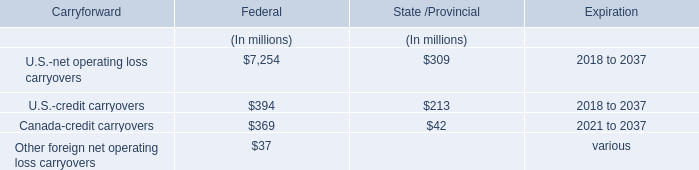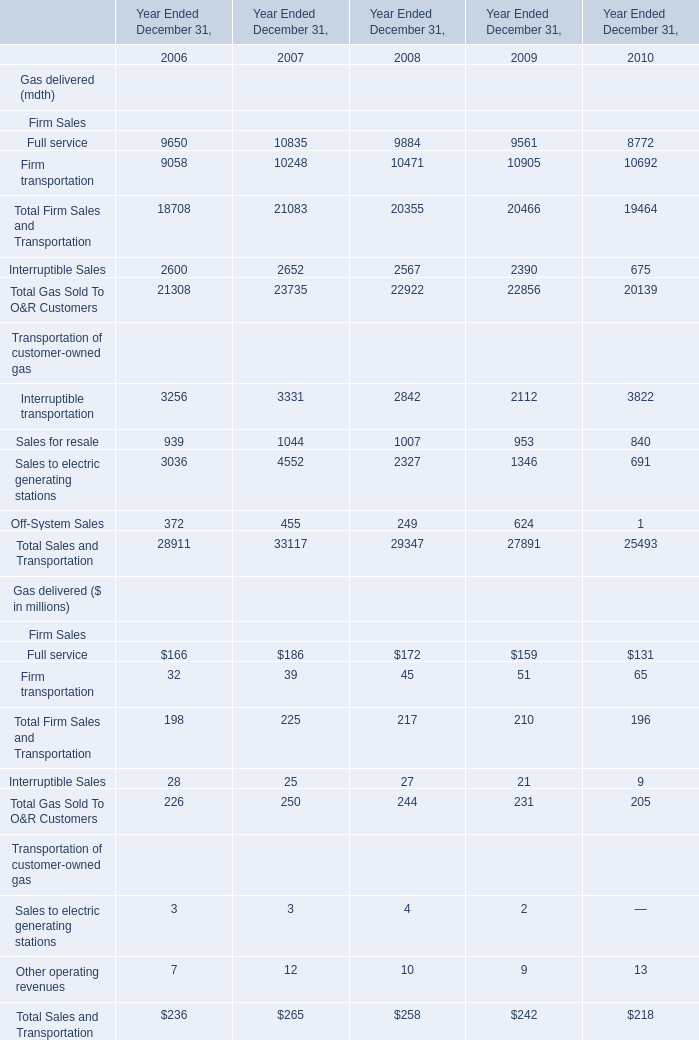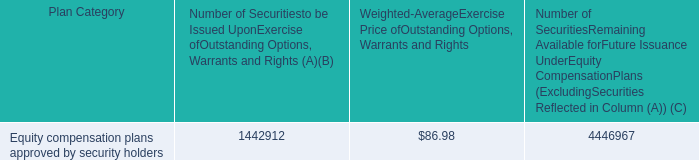what is the total value of the options , warrants and rights that remain available for future issuance , ( in millions ) ? 
Computations: ((4446967 * 86.98) / 1000000)
Answer: 386.79719. 